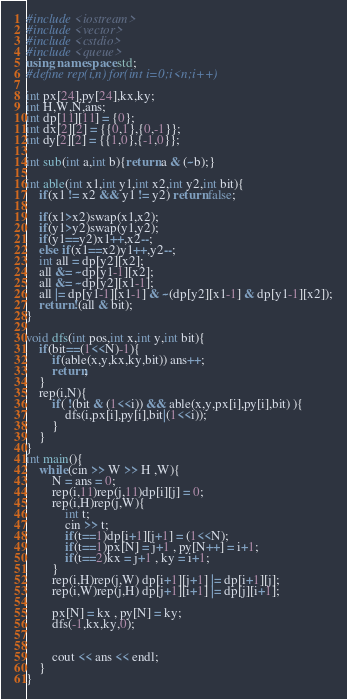<code> <loc_0><loc_0><loc_500><loc_500><_C++_>#include <iostream>
#include <vector>
#include <cstdio>
#include <queue>
using namespace std;
#define rep(i,n) for(int i=0;i<n;i++)

int px[24],py[24],kx,ky;
int H,W,N,ans;
int dp[11][11] = {0};
int dx[2][2] = {{0,1},{0,-1}};
int dy[2][2] = {{1,0},{-1,0}};

int sub(int a,int b){return a & (~b);}

int able(int x1,int y1,int x2,int y2,int bit){
	if(x1 != x2 && y1 != y2) return false;
	
	if(x1>x2)swap(x1,x2);
	if(y1>y2)swap(y1,y2);
	if(y1==y2)x1++,x2--;
	else if(x1==x2)y1++,y2--;
	int all = dp[y2][x2];
	all &= ~dp[y1-1][x2];
	all &= ~dp[y2][x1-1];
	all |= dp[y1-1][x1-1] & ~(dp[y2][x1-1] & dp[y1-1][x2]);
	return !(all & bit);
}

void dfs(int pos,int x,int y,int bit){
	if(bit==(1<<N)-1){
		if(able(x,y,kx,ky,bit)) ans++;
		return;
	}
	rep(i,N){
		if( !(bit & (1<<i)) && able(x,y,px[i],py[i],bit) ){
			dfs(i,px[i],py[i],bit|(1<<i));
		}
	}
}
int main(){
	while(cin >> W >> H ,W){
		N = ans = 0;
		rep(i,11)rep(j,11)dp[i][j] = 0;
		rep(i,H)rep(j,W){
			int t;
			cin >> t;
			if(t==1)dp[i+1][j+1] = (1<<N);
			if(t==1)px[N] = j+1 , py[N++] = i+1;
			if(t==2)kx = j+1 , ky = i+1;
		}
		rep(i,H)rep(j,W) dp[i+1][j+1] |= dp[i+1][j];
		rep(i,W)rep(j,H) dp[j+1][i+1] |= dp[j][i+1]; 
		
		px[N] = kx , py[N] = ky;
		dfs(-1,kx,ky,0);
		
		
		cout << ans << endl;
	}
}</code> 